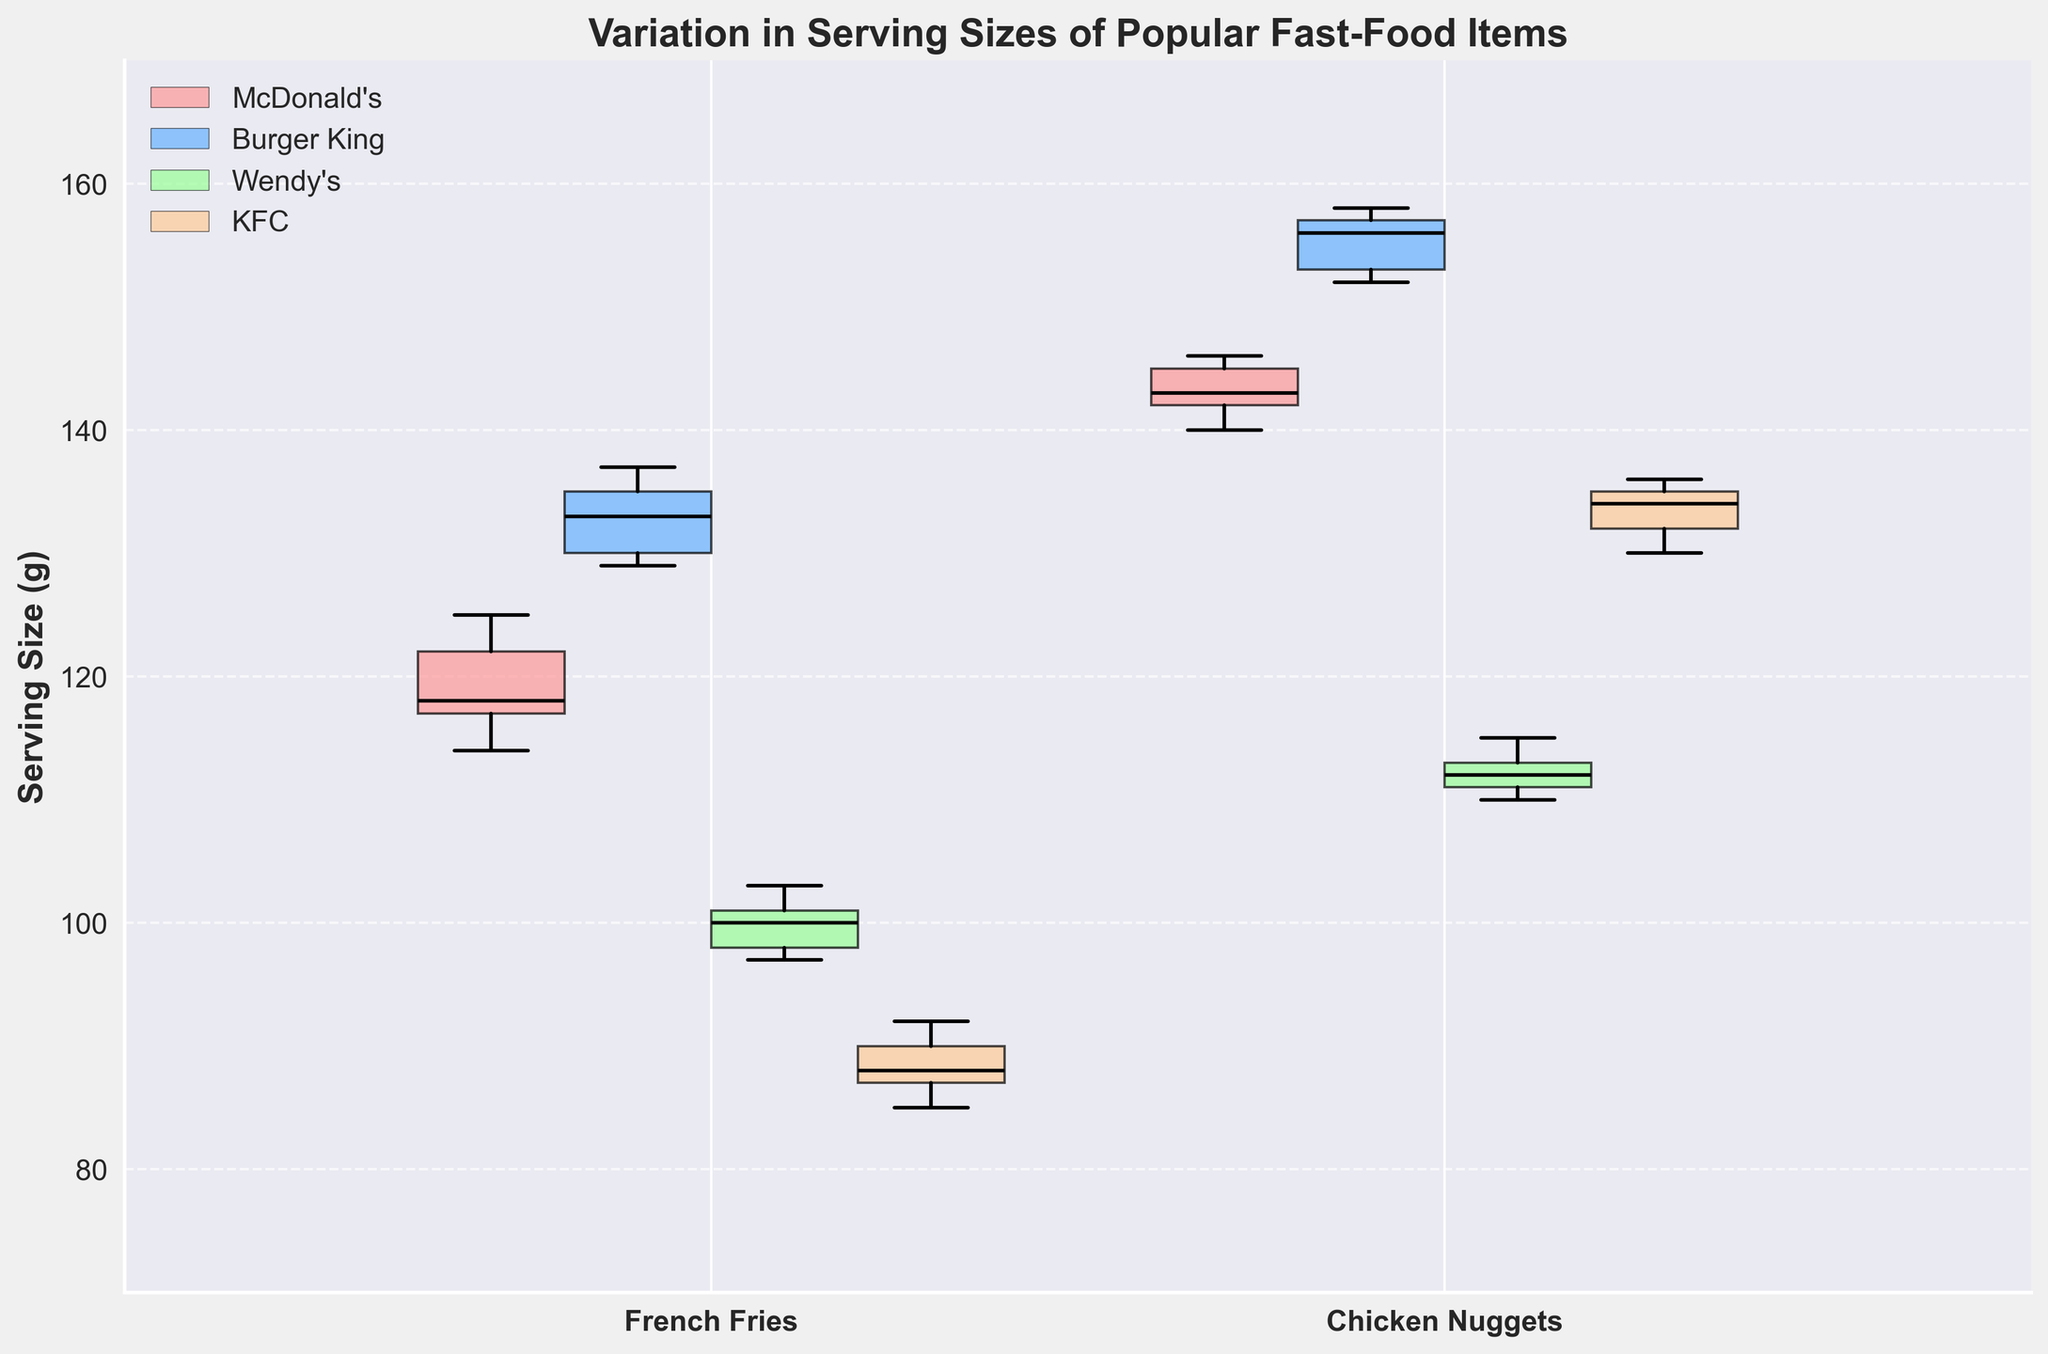What's the title of the plot? The title is text at the top of the plot, typically explaining what the plot represents.
Answer: Variation in Serving Sizes of Popular Fast-Food Items How many unique items are represented in the plot? There are four notches visible for each restaurant, which means four unique items.
Answer: 4 What is the serving size range of French Fries at Wendy's? The range is determined by the lowest and highest whisker points of the notched box, which represent the minimum and maximum serving sizes.
Answer: 97-103 grams Which restaurant has the highest median serving size for Chicken Nuggets? The highest median is where the solid black line inside the box is at its highest point for Chicken Nuggets.
Answer: Burger King Are the serving sizes of French Fries at KFC more consistent than McDonald’s? Consistency can be inferred from the width of the notches and the interquartile range (IQR); a narrower box indicates less variability. KFC's box is narrower than McDonald's.
Answer: Yes What restaurant has the largest interquartile range (IQR) for French Fries? The IQR is the height of the colored box (from the bottom to the top of the box). The box height of Burger King's French Fries is the largest.
Answer: Burger King Based on the plot, which item has the smallest variation in serving size at KFC? The smallest variation is indicated by the narrowest box (smallest height) at KFC.
Answer: Chicken Nuggets Is there any outlier in the serving size for French Fries at McDonald’s? Outliers are represented by individual points outside the whiskers. There are no additional points for McDonald's French Fries.
Answer: No Which item’s serving size appears to be most variable based on their notch widths? Greater notch width indicates more variability. The largest notch width is seen for French Fries at Burger King.
Answer: French Fries at Burger King 